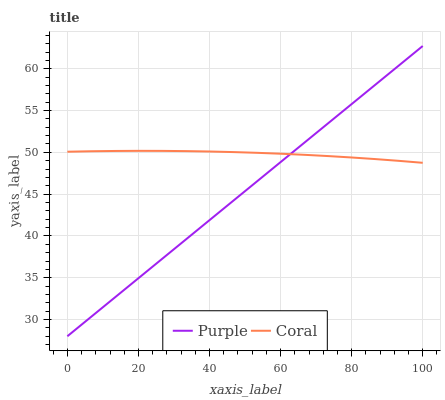Does Purple have the minimum area under the curve?
Answer yes or no. Yes. Does Coral have the maximum area under the curve?
Answer yes or no. Yes. Does Coral have the minimum area under the curve?
Answer yes or no. No. Is Purple the smoothest?
Answer yes or no. Yes. Is Coral the roughest?
Answer yes or no. Yes. Is Coral the smoothest?
Answer yes or no. No. Does Purple have the lowest value?
Answer yes or no. Yes. Does Coral have the lowest value?
Answer yes or no. No. Does Purple have the highest value?
Answer yes or no. Yes. Does Coral have the highest value?
Answer yes or no. No. Does Coral intersect Purple?
Answer yes or no. Yes. Is Coral less than Purple?
Answer yes or no. No. Is Coral greater than Purple?
Answer yes or no. No. 